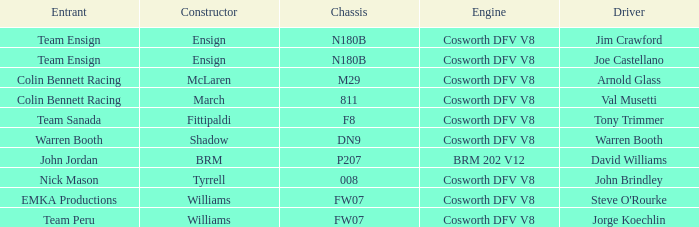Who was responsible for constructing the jim crawford car? Ensign. 